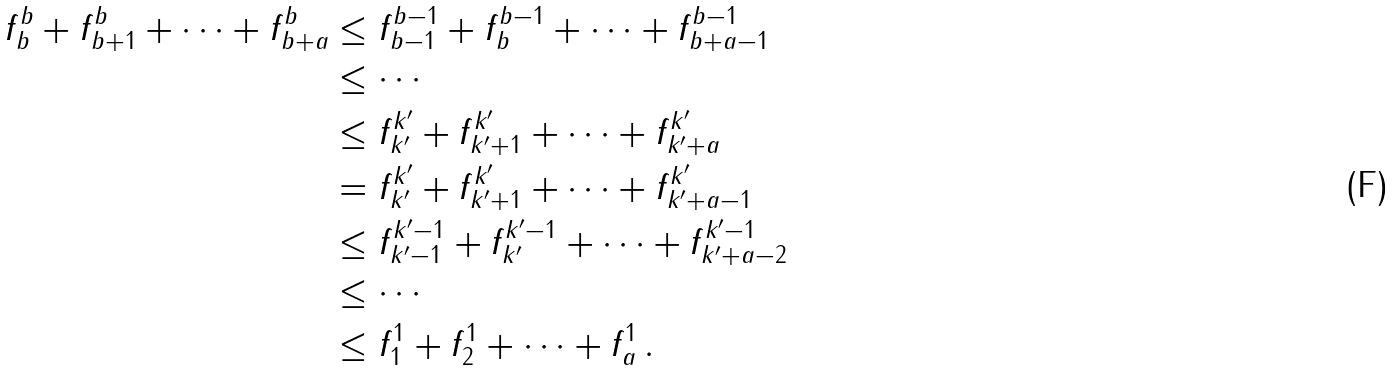<formula> <loc_0><loc_0><loc_500><loc_500>f ^ { b } _ { b } + f ^ { b } _ { b + 1 } + \cdots + f ^ { b } _ { b + a } & \leq f ^ { b - 1 } _ { b - 1 } + f ^ { b - 1 } _ { b } + \cdots + f ^ { b - 1 } _ { b + a - 1 } \\ & \leq \cdots \\ & \leq f ^ { k ^ { \prime } } _ { k ^ { \prime } } + f ^ { k ^ { \prime } } _ { k ^ { \prime } + 1 } + \cdots + f ^ { k ^ { \prime } } _ { k ^ { \prime } + a } \\ & = f ^ { k ^ { \prime } } _ { k ^ { \prime } } + f ^ { k ^ { \prime } } _ { k ^ { \prime } + 1 } + \cdots + f ^ { k ^ { \prime } } _ { k ^ { \prime } + a - 1 } \\ & \leq f ^ { k ^ { \prime } - 1 } _ { k ^ { \prime } - 1 } + f ^ { k ^ { \prime } - 1 } _ { k ^ { \prime } } + \cdots + f ^ { k ^ { \prime } - 1 } _ { k ^ { \prime } + a - 2 } \\ & \leq \cdots \\ & \leq f ^ { 1 } _ { 1 } + f ^ { 1 } _ { 2 } + \cdots + f ^ { 1 } _ { a } \, .</formula> 